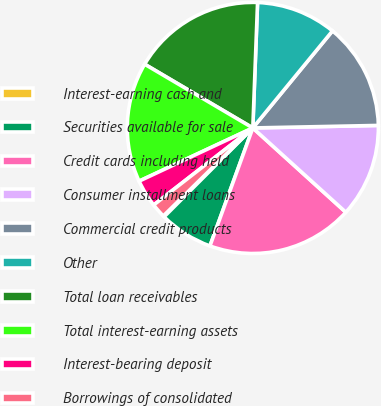Convert chart to OTSL. <chart><loc_0><loc_0><loc_500><loc_500><pie_chart><fcel>Interest-earning cash and<fcel>Securities available for sale<fcel>Credit cards including held<fcel>Consumer installment loans<fcel>Commercial credit products<fcel>Other<fcel>Total loan receivables<fcel>Total interest-earning assets<fcel>Interest-bearing deposit<fcel>Borrowings of consolidated<nl><fcel>0.15%<fcel>6.94%<fcel>18.83%<fcel>12.04%<fcel>13.74%<fcel>10.34%<fcel>17.13%<fcel>15.44%<fcel>3.55%<fcel>1.85%<nl></chart> 